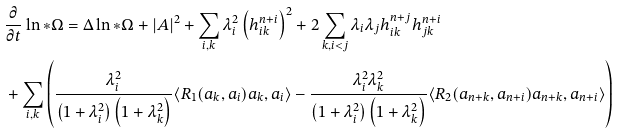<formula> <loc_0><loc_0><loc_500><loc_500>& \frac { \partial } { \partial t } \ln * \Omega = \Delta \ln * \Omega + | A | ^ { 2 } + \sum _ { i , k } \lambda _ { i } ^ { 2 } \left ( h _ { i k } ^ { n + i } \right ) ^ { 2 } + 2 \sum _ { k , i < j } \lambda _ { i } \lambda _ { j } h _ { i k } ^ { n + j } h _ { j k } ^ { n + i } \\ & + \sum _ { i , k } \left ( \frac { \lambda _ { i } ^ { 2 } } { \left ( 1 + \lambda _ { i } ^ { 2 } \right ) \left ( 1 + \lambda _ { k } ^ { 2 } \right ) } \langle R _ { 1 } ( a _ { k } , a _ { i } ) a _ { k } , a _ { i } \rangle - \frac { \lambda _ { i } ^ { 2 } \lambda _ { k } ^ { 2 } } { \left ( 1 + \lambda _ { i } ^ { 2 } \right ) \left ( 1 + \lambda _ { k } ^ { 2 } \right ) } \langle R _ { 2 } ( a _ { n + k } , a _ { n + i } ) a _ { n + k } , a _ { n + i } \rangle \right )</formula> 